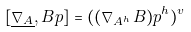<formula> <loc_0><loc_0><loc_500><loc_500>[ \underline { \nabla _ { A } } , B p ] = ( ( \nabla _ { A ^ { h } } B ) p ^ { h } ) ^ { v }</formula> 